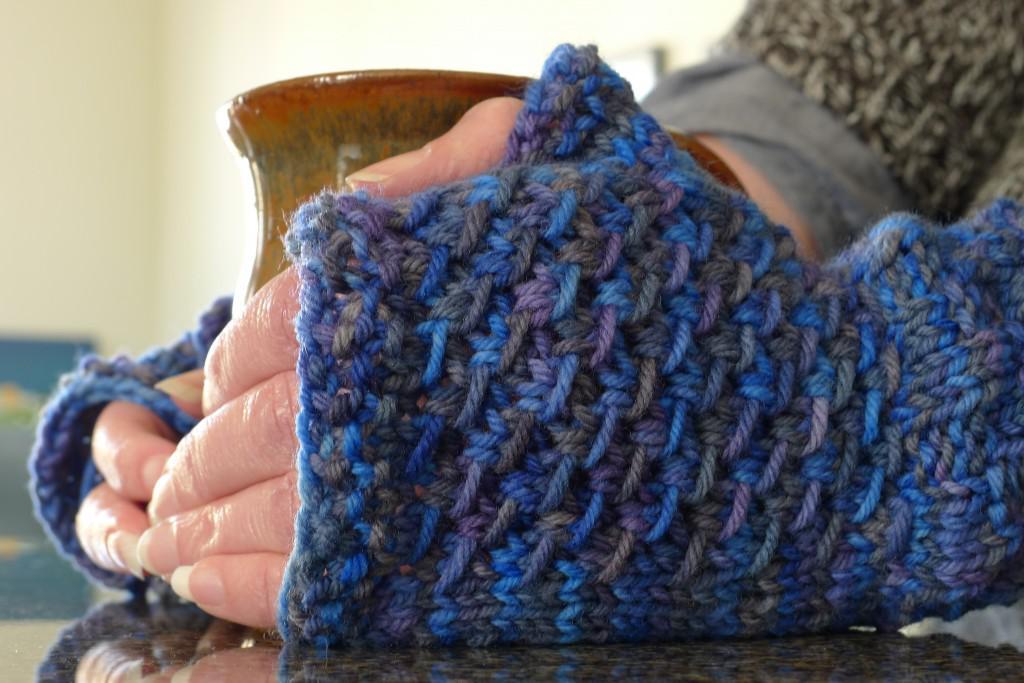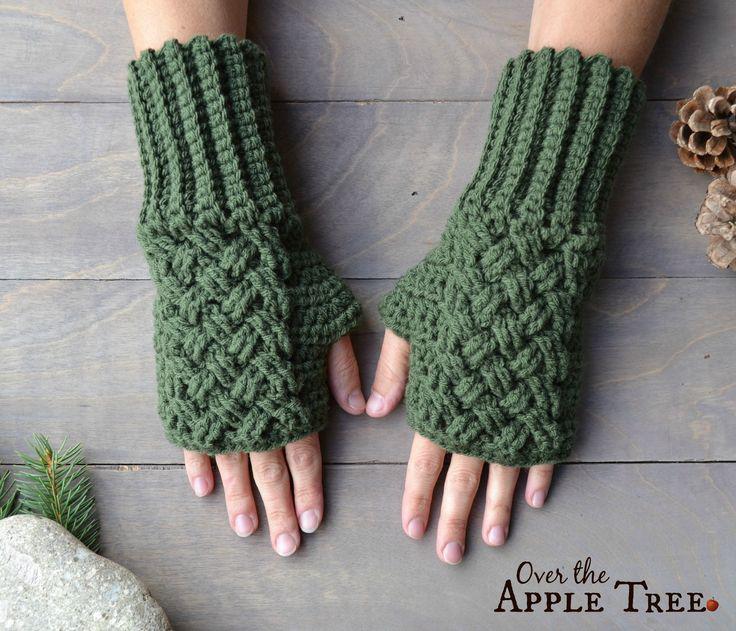The first image is the image on the left, the second image is the image on the right. Given the left and right images, does the statement "Solid color mittens appear in each image, a different color and pattern in each one, with one pair worn by a person." hold true? Answer yes or no. No. The first image is the image on the left, the second image is the image on the right. Examine the images to the left and right. Is the description "The person's skin is visible as they try on the gloves." accurate? Answer yes or no. Yes. 